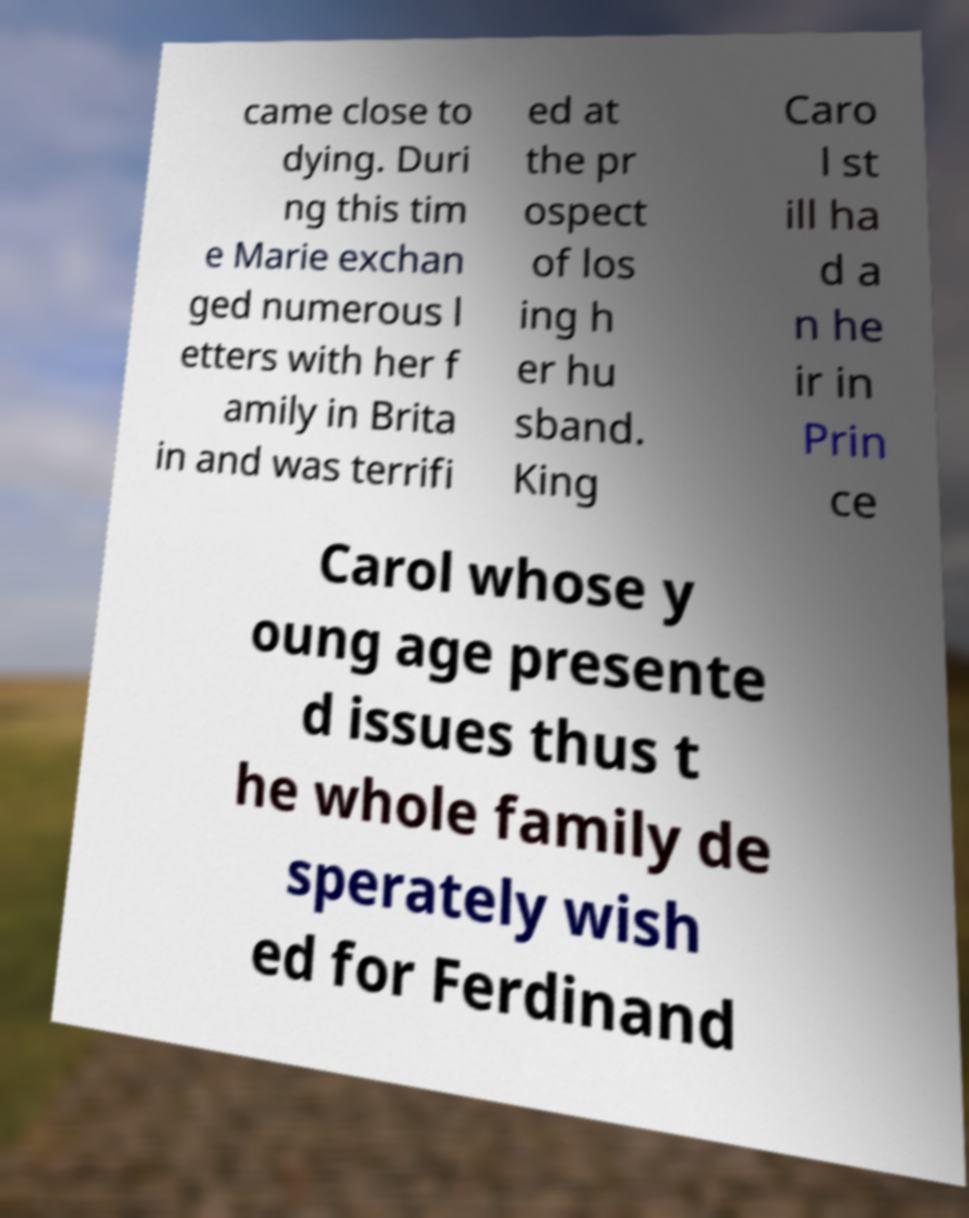I need the written content from this picture converted into text. Can you do that? came close to dying. Duri ng this tim e Marie exchan ged numerous l etters with her f amily in Brita in and was terrifi ed at the pr ospect of los ing h er hu sband. King Caro l st ill ha d a n he ir in Prin ce Carol whose y oung age presente d issues thus t he whole family de sperately wish ed for Ferdinand 